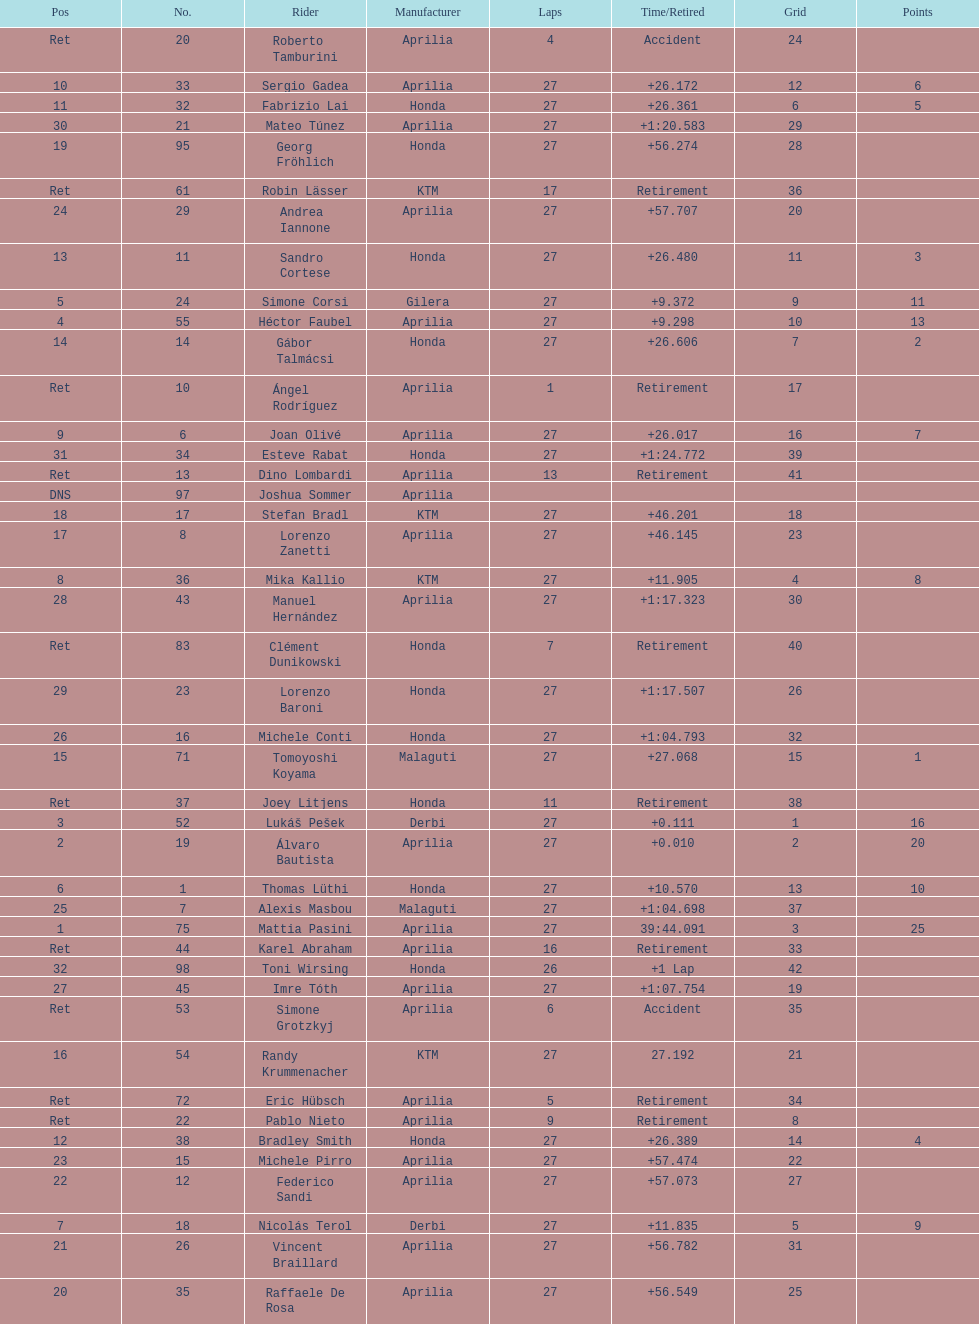What was the total number of positions in the 125cc classification? 43. 